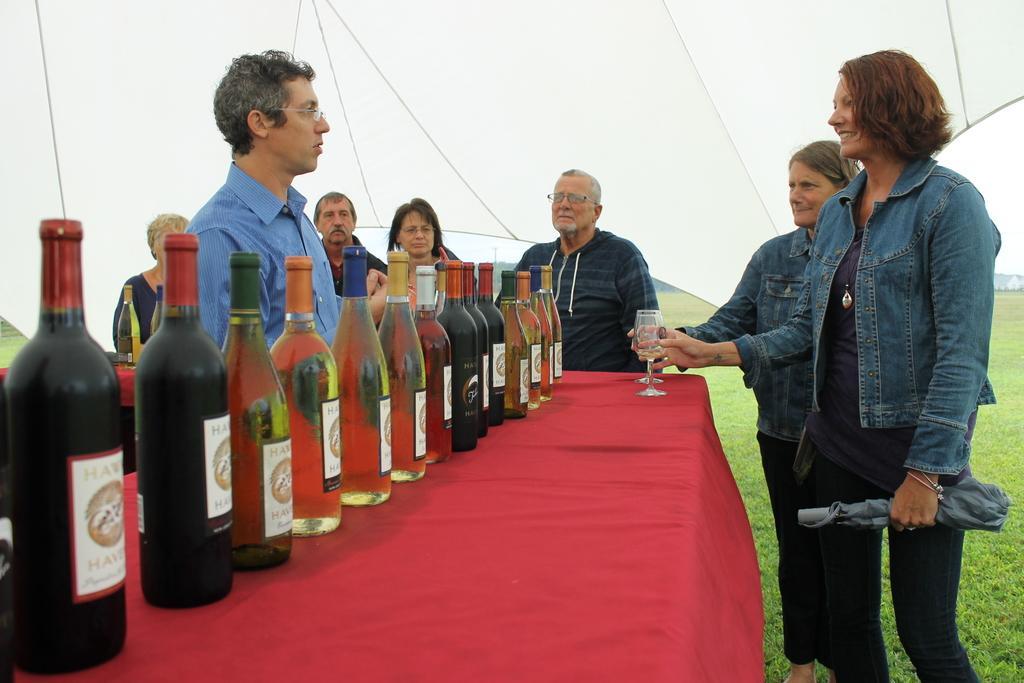How would you summarize this image in a sentence or two? In the picture we can find a desk and a wine bottles on it near to the table we can find some people, and two women are holding a glasses on the table, on the table we can see red cloth, in the background we can find a sky, tent and grass. 